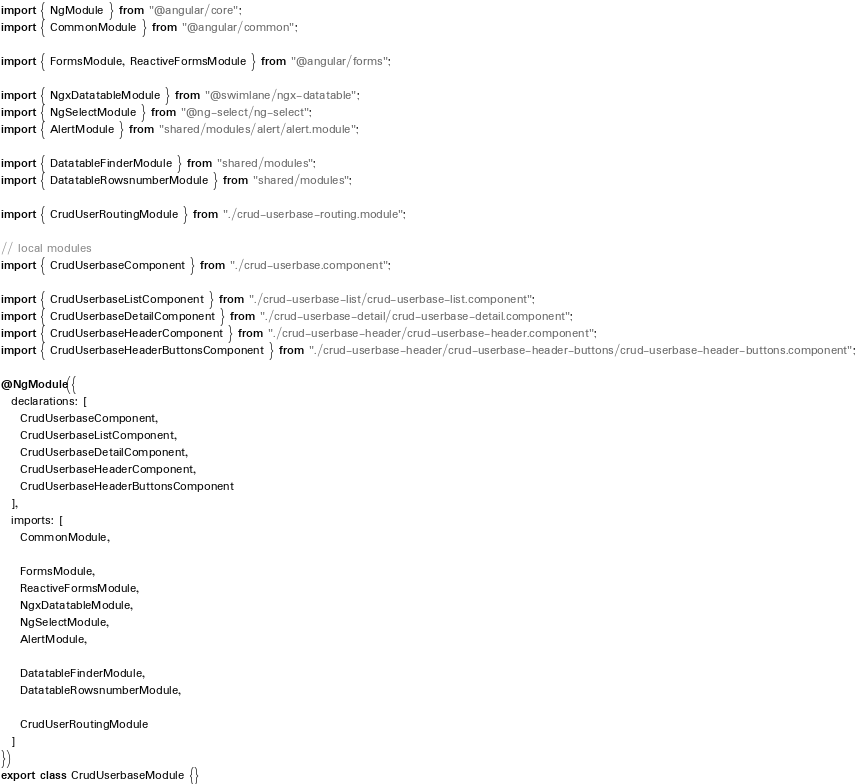Convert code to text. <code><loc_0><loc_0><loc_500><loc_500><_TypeScript_>import { NgModule } from "@angular/core";
import { CommonModule } from "@angular/common";

import { FormsModule, ReactiveFormsModule } from "@angular/forms";

import { NgxDatatableModule } from "@swimlane/ngx-datatable";
import { NgSelectModule } from "@ng-select/ng-select";
import { AlertModule } from "shared/modules/alert/alert.module";

import { DatatableFinderModule } from "shared/modules";
import { DatatableRowsnumberModule } from "shared/modules";

import { CrudUserRoutingModule } from "./crud-userbase-routing.module";

// local modules
import { CrudUserbaseComponent } from "./crud-userbase.component";

import { CrudUserbaseListComponent } from "./crud-userbase-list/crud-userbase-list.component";
import { CrudUserbaseDetailComponent } from "./crud-userbase-detail/crud-userbase-detail.component";
import { CrudUserbaseHeaderComponent } from "./crud-userbase-header/crud-userbase-header.component";
import { CrudUserbaseHeaderButtonsComponent } from "./crud-userbase-header/crud-userbase-header-buttons/crud-userbase-header-buttons.component";

@NgModule({
  declarations: [
    CrudUserbaseComponent,
    CrudUserbaseListComponent,
    CrudUserbaseDetailComponent,
    CrudUserbaseHeaderComponent,
    CrudUserbaseHeaderButtonsComponent
  ],
  imports: [
    CommonModule,

    FormsModule,
    ReactiveFormsModule,
    NgxDatatableModule,
    NgSelectModule,
    AlertModule,

    DatatableFinderModule,
    DatatableRowsnumberModule,

    CrudUserRoutingModule
  ]
})
export class CrudUserbaseModule {}
</code> 